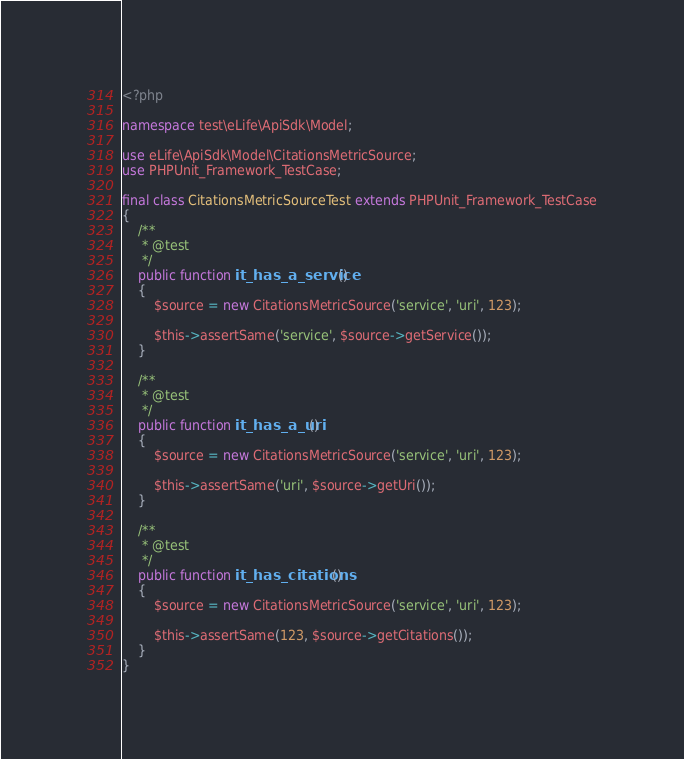Convert code to text. <code><loc_0><loc_0><loc_500><loc_500><_PHP_><?php

namespace test\eLife\ApiSdk\Model;

use eLife\ApiSdk\Model\CitationsMetricSource;
use PHPUnit_Framework_TestCase;

final class CitationsMetricSourceTest extends PHPUnit_Framework_TestCase
{
    /**
     * @test
     */
    public function it_has_a_service()
    {
        $source = new CitationsMetricSource('service', 'uri', 123);

        $this->assertSame('service', $source->getService());
    }

    /**
     * @test
     */
    public function it_has_a_uri()
    {
        $source = new CitationsMetricSource('service', 'uri', 123);

        $this->assertSame('uri', $source->getUri());
    }

    /**
     * @test
     */
    public function it_has_citations()
    {
        $source = new CitationsMetricSource('service', 'uri', 123);

        $this->assertSame(123, $source->getCitations());
    }
}
</code> 